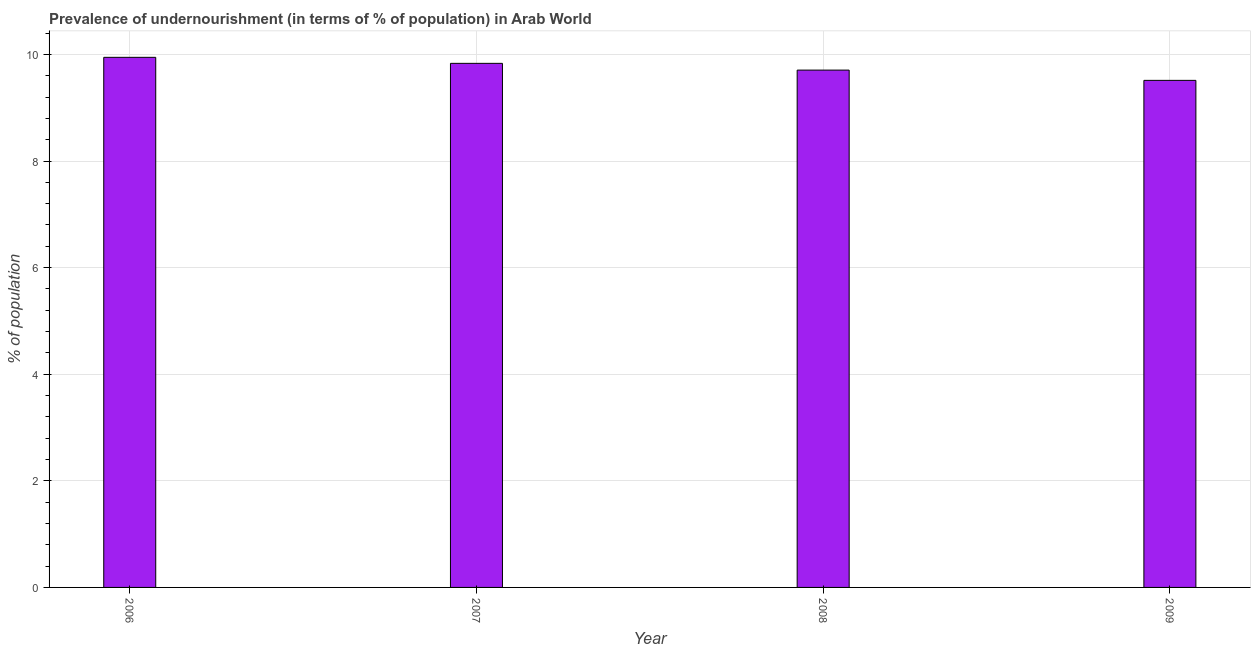What is the title of the graph?
Ensure brevity in your answer.  Prevalence of undernourishment (in terms of % of population) in Arab World. What is the label or title of the X-axis?
Give a very brief answer. Year. What is the label or title of the Y-axis?
Provide a succinct answer. % of population. What is the percentage of undernourished population in 2008?
Offer a terse response. 9.71. Across all years, what is the maximum percentage of undernourished population?
Ensure brevity in your answer.  9.95. Across all years, what is the minimum percentage of undernourished population?
Ensure brevity in your answer.  9.51. In which year was the percentage of undernourished population maximum?
Your response must be concise. 2006. What is the sum of the percentage of undernourished population?
Offer a very short reply. 39. What is the difference between the percentage of undernourished population in 2008 and 2009?
Keep it short and to the point. 0.19. What is the average percentage of undernourished population per year?
Ensure brevity in your answer.  9.75. What is the median percentage of undernourished population?
Keep it short and to the point. 9.77. In how many years, is the percentage of undernourished population greater than 4.4 %?
Offer a very short reply. 4. What is the ratio of the percentage of undernourished population in 2006 to that in 2009?
Your answer should be very brief. 1.04. What is the difference between the highest and the second highest percentage of undernourished population?
Your response must be concise. 0.11. Is the sum of the percentage of undernourished population in 2006 and 2008 greater than the maximum percentage of undernourished population across all years?
Offer a terse response. Yes. What is the difference between the highest and the lowest percentage of undernourished population?
Make the answer very short. 0.43. Are all the bars in the graph horizontal?
Ensure brevity in your answer.  No. What is the difference between two consecutive major ticks on the Y-axis?
Keep it short and to the point. 2. What is the % of population of 2006?
Your response must be concise. 9.95. What is the % of population of 2007?
Offer a very short reply. 9.83. What is the % of population in 2008?
Your answer should be compact. 9.71. What is the % of population in 2009?
Your answer should be very brief. 9.51. What is the difference between the % of population in 2006 and 2007?
Your answer should be compact. 0.11. What is the difference between the % of population in 2006 and 2008?
Your answer should be very brief. 0.24. What is the difference between the % of population in 2006 and 2009?
Keep it short and to the point. 0.43. What is the difference between the % of population in 2007 and 2008?
Provide a succinct answer. 0.13. What is the difference between the % of population in 2007 and 2009?
Ensure brevity in your answer.  0.32. What is the difference between the % of population in 2008 and 2009?
Offer a very short reply. 0.19. What is the ratio of the % of population in 2006 to that in 2007?
Keep it short and to the point. 1.01. What is the ratio of the % of population in 2006 to that in 2008?
Your answer should be very brief. 1.02. What is the ratio of the % of population in 2006 to that in 2009?
Your answer should be very brief. 1.04. What is the ratio of the % of population in 2007 to that in 2008?
Give a very brief answer. 1.01. What is the ratio of the % of population in 2007 to that in 2009?
Give a very brief answer. 1.03. What is the ratio of the % of population in 2008 to that in 2009?
Make the answer very short. 1.02. 